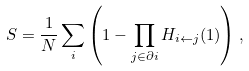<formula> <loc_0><loc_0><loc_500><loc_500>S = \frac { 1 } { N } \sum _ { i } \left ( 1 - \prod _ { j \in \partial i } H _ { i \leftarrow j } ( 1 ) \right ) ,</formula> 